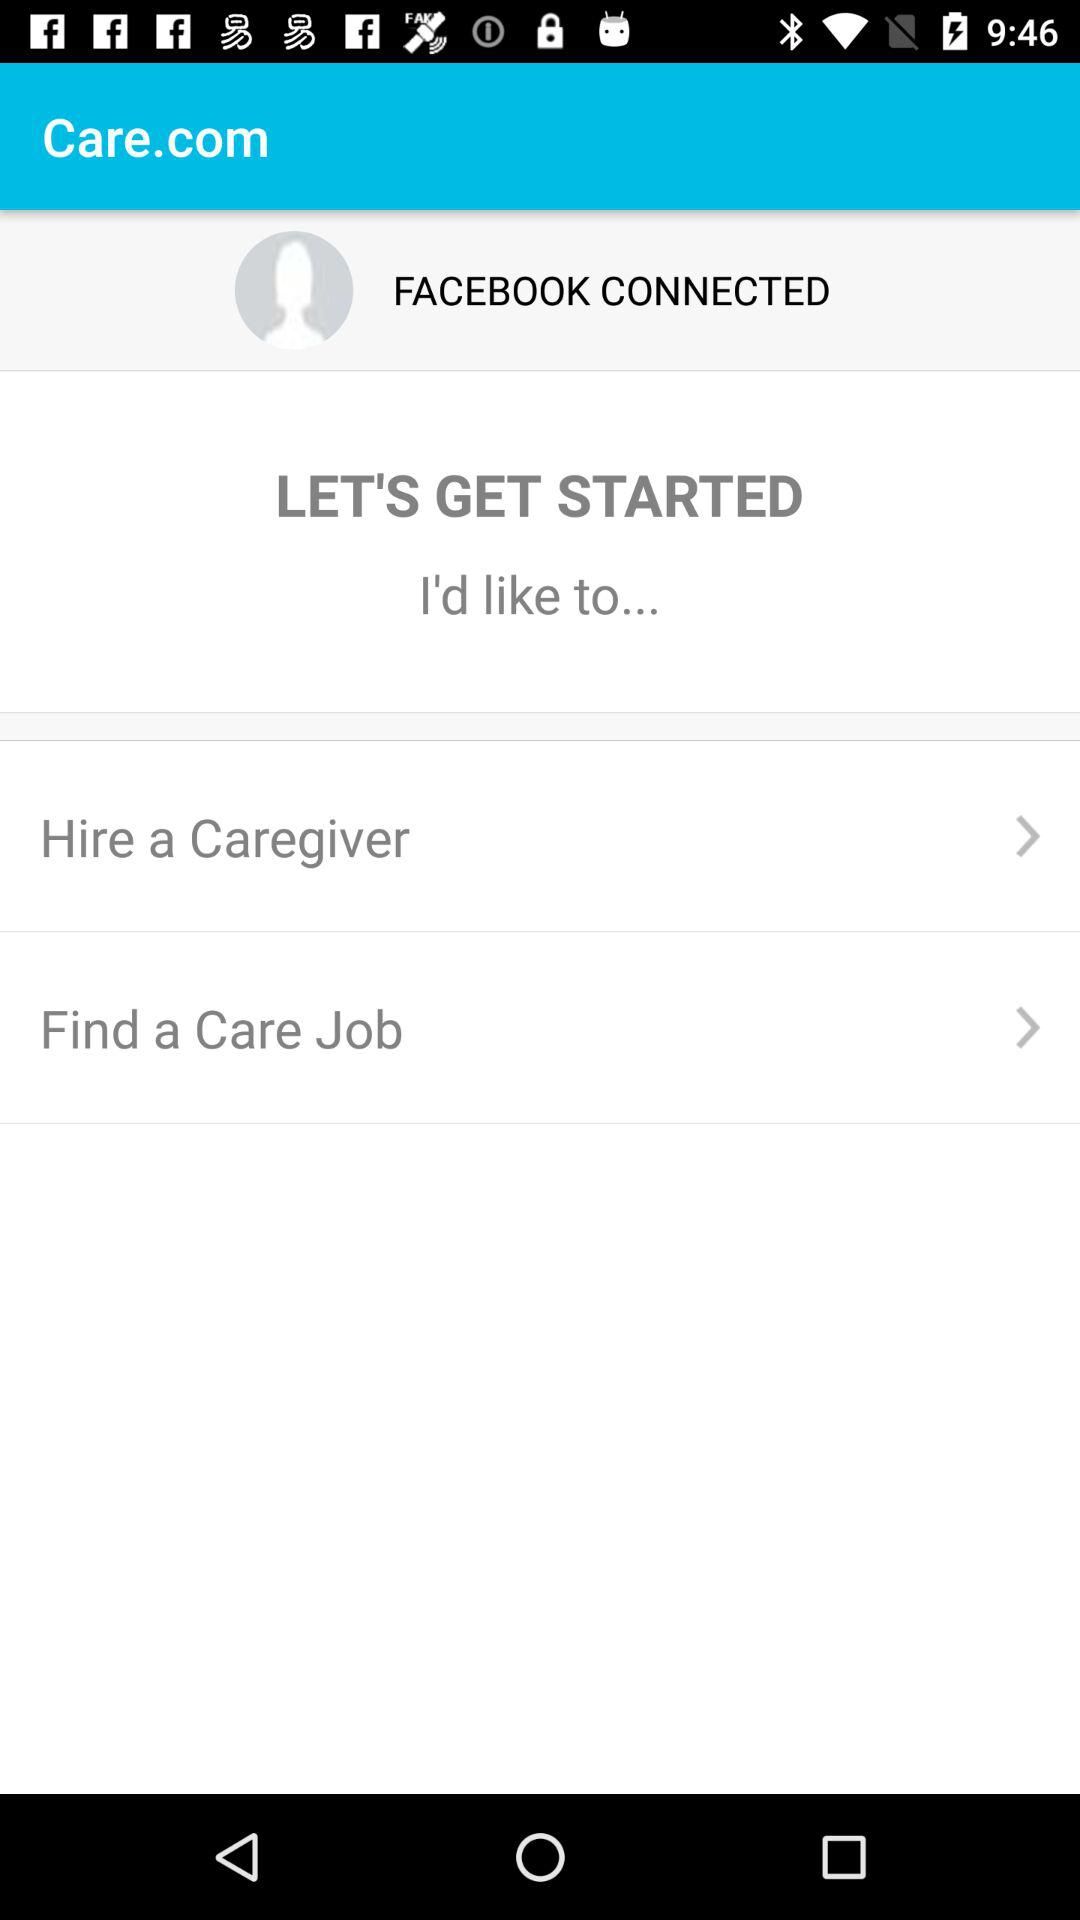What is the application name? The application name is "Care.com". 